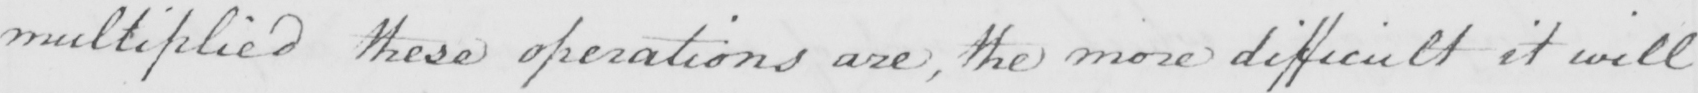Can you read and transcribe this handwriting? multiplied these operations are , the more difficult it will 